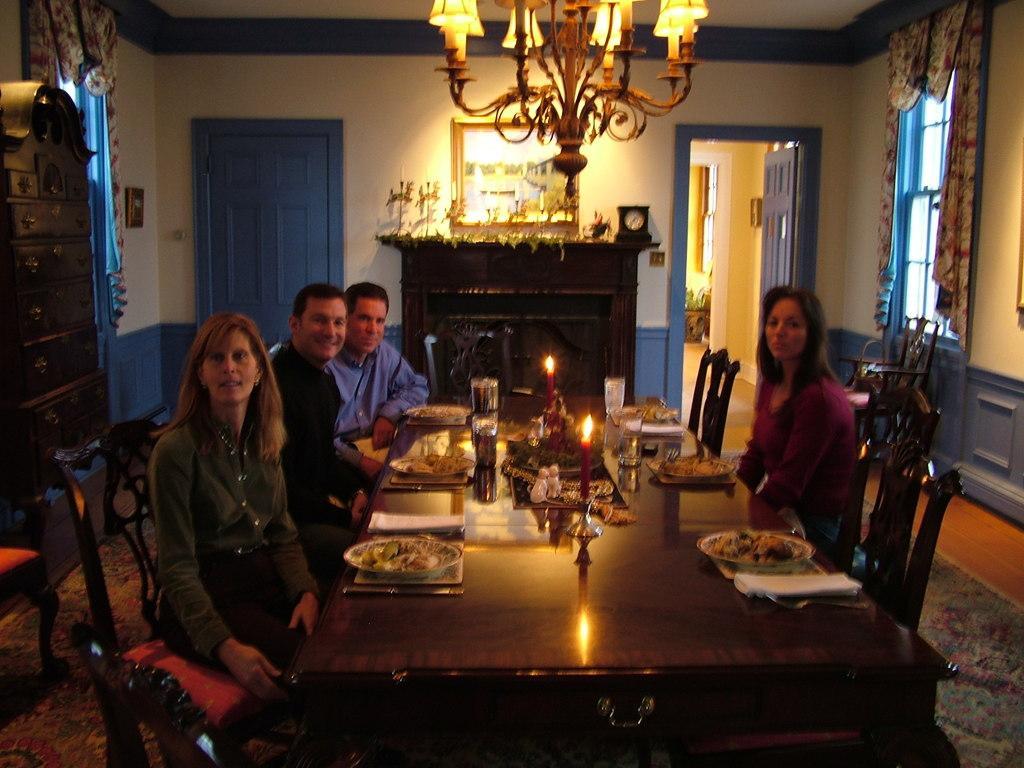In one or two sentences, can you explain what this image depicts? In this image i can see two man and two women sitting on a chair there are few candles on table at the back ground i can see a wall, a door, at the top i can see chandelier. 